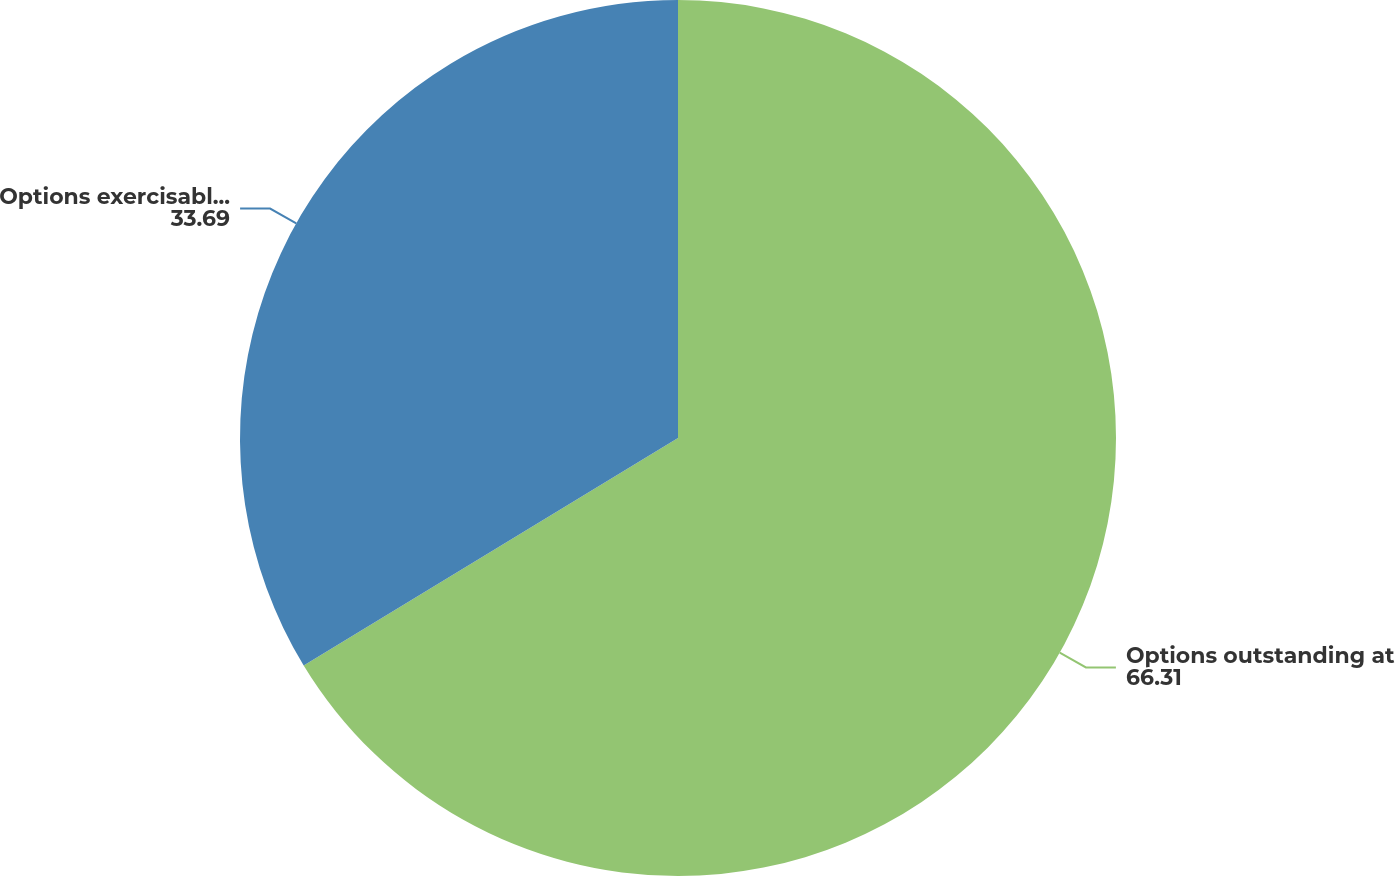Convert chart. <chart><loc_0><loc_0><loc_500><loc_500><pie_chart><fcel>Options outstanding at<fcel>Options exercisable at<nl><fcel>66.31%<fcel>33.69%<nl></chart> 